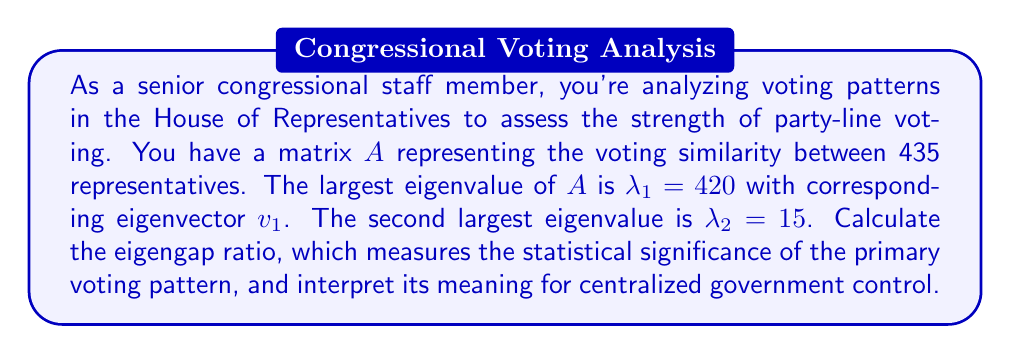Can you solve this math problem? To solve this problem, we need to follow these steps:

1) The eigengap ratio is defined as the ratio of the difference between the two largest eigenvalues to the largest eigenvalue. It's calculated as:

   $$\text{Eigengap Ratio} = \frac{\lambda_1 - \lambda_2}{\lambda_1}$$

2) We're given:
   $\lambda_1 = 420$ (largest eigenvalue)
   $\lambda_2 = 15$ (second largest eigenvalue)

3) Let's substitute these values into our formula:

   $$\text{Eigengap Ratio} = \frac{420 - 15}{420} = \frac{405}{420}$$

4) Simplify the fraction:

   $$\text{Eigengap Ratio} = 0.9643$$

5) Interpretation: 
   The eigengap ratio ranges from 0 to 1, with values closer to 1 indicating a more significant primary voting pattern. Our result of 0.9643 is very close to 1, suggesting a highly significant primary voting pattern.

   For a congressional staff member advocating for a strong centralized government, this high eigengap ratio implies that voting in the House is highly structured and predictable. It suggests that party-line voting is very strong, which could be seen as an opportunity for centralized control and coordination of legislative efforts.
Answer: The eigengap ratio is 0.9643, indicating a highly significant primary voting pattern that aligns strongly with party lines, potentially facilitating centralized government control over legislative processes. 